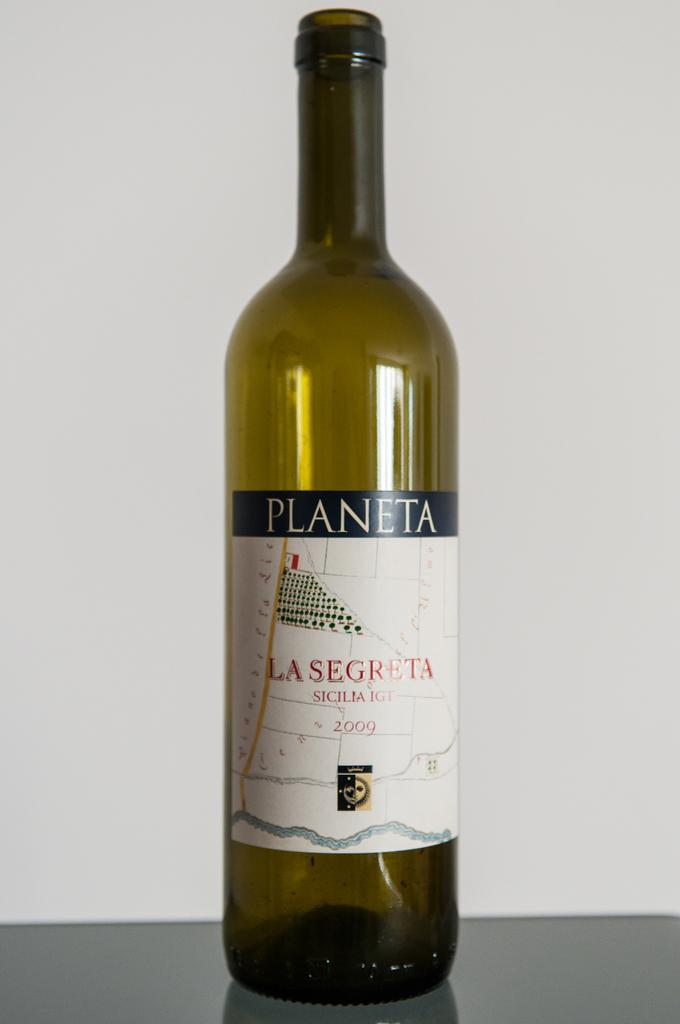What object is on the floor in the image? There is a beverage bottle on the floor in the image. What color is the background wall in the image? The background wall is white in the image. Where was the image taken? The image was taken inside a room. What type of cracker is being used to answer the questions in the image? There is no cracker present in the image, and no one is answering questions. 